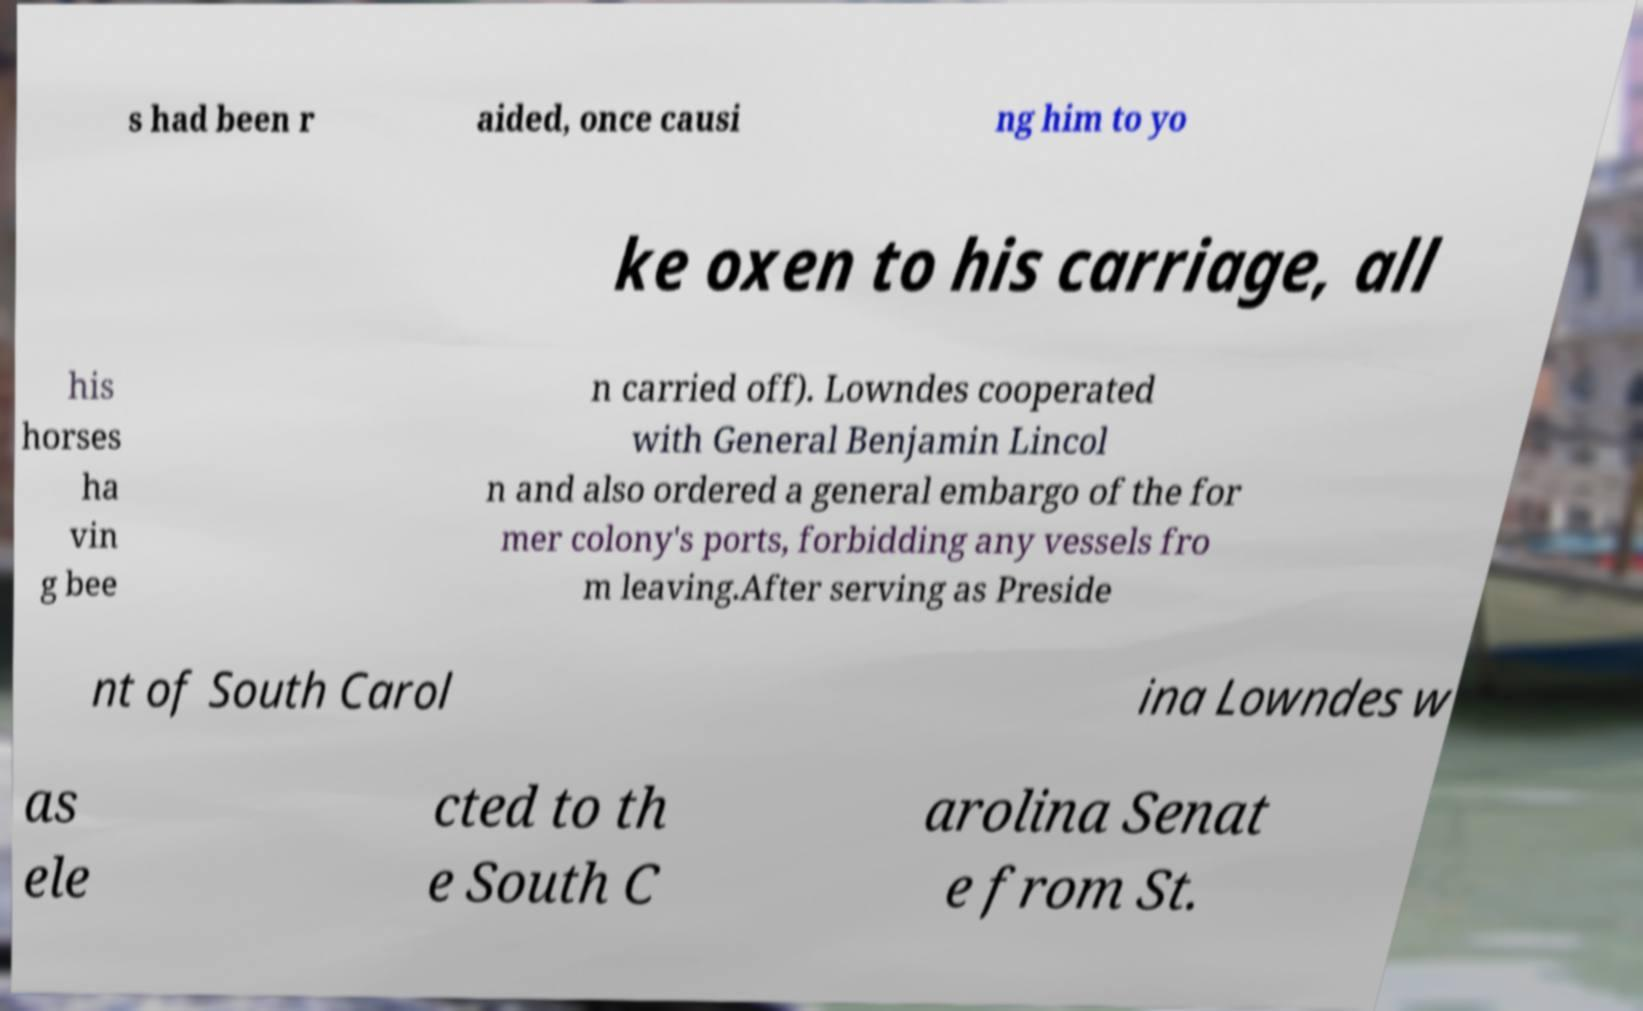Can you read and provide the text displayed in the image?This photo seems to have some interesting text. Can you extract and type it out for me? s had been r aided, once causi ng him to yo ke oxen to his carriage, all his horses ha vin g bee n carried off). Lowndes cooperated with General Benjamin Lincol n and also ordered a general embargo of the for mer colony's ports, forbidding any vessels fro m leaving.After serving as Preside nt of South Carol ina Lowndes w as ele cted to th e South C arolina Senat e from St. 